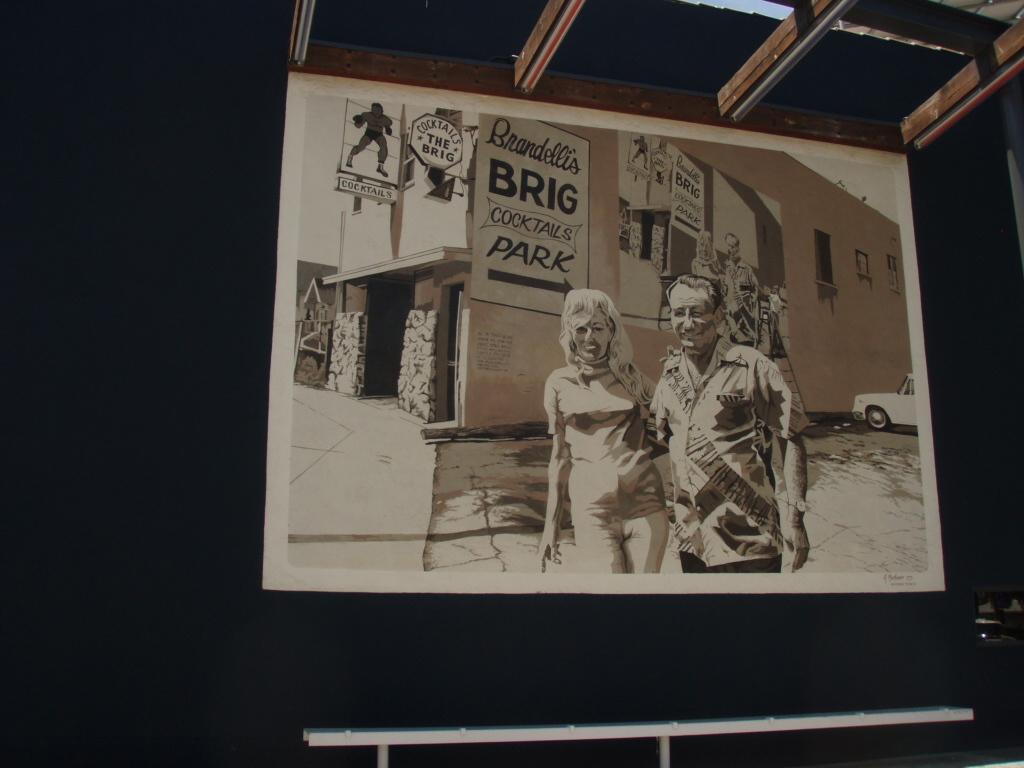What park is it?
Your answer should be compact. Brig. 